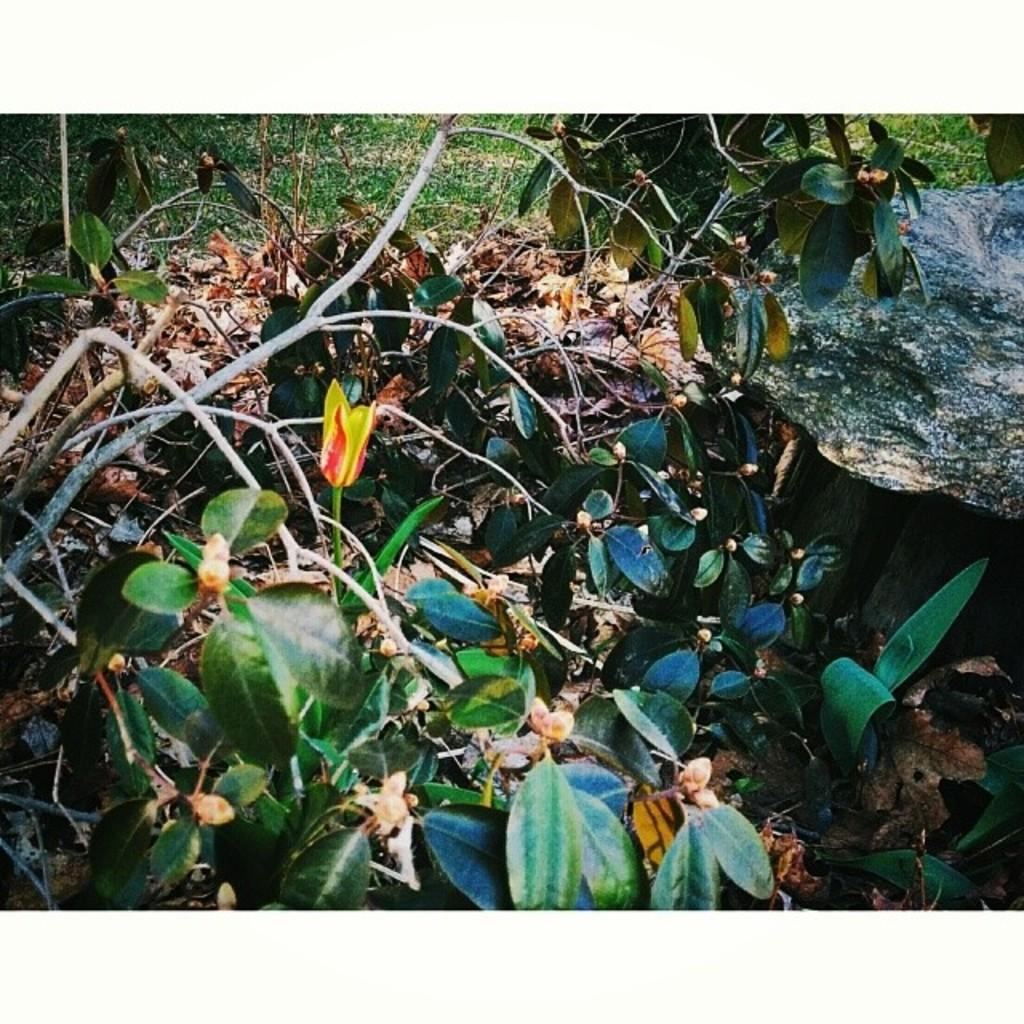What type of living organisms are in the image? Plants are in the image. What part of the plants can be seen in the image? Leaves and branches can be seen in the image. Are there any fallen leaves in the image? Yes, there are dry leaves in the image. What type of organization is depicted in the image? There is no organization depicted in the image; it features plants, leaves, dry leaves, and branches. What type of plate is visible in the image? There is no plate present in the image. 